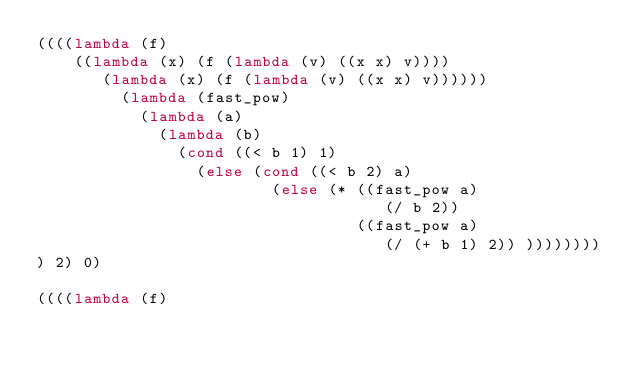Convert code to text. <code><loc_0><loc_0><loc_500><loc_500><_Scheme_>((((lambda (f)
    ((lambda (x) (f (lambda (v) ((x x) v))))
       (lambda (x) (f (lambda (v) ((x x) v))))))
         (lambda (fast_pow)
           (lambda (a)
             (lambda (b)
               (cond ((< b 1) 1)
                 (else (cond ((< b 2) a)
                         (else (* ((fast_pow a)
                                     (/ b 2))
                                  ((fast_pow a)
                                     (/ (+ b 1) 2)) ))))))))
) 2) 0)

((((lambda (f)</code> 